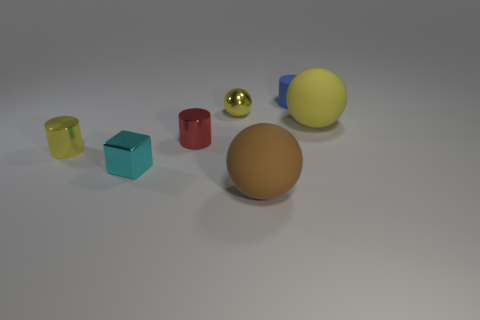The blue matte cylinder has what size?
Make the answer very short. Small. What number of things are yellow spheres or large brown objects?
Provide a succinct answer. 3. There is a tiny sphere that is the same material as the tiny cyan object; what color is it?
Make the answer very short. Yellow. There is a object that is to the right of the tiny blue cylinder; is it the same shape as the cyan metallic thing?
Your response must be concise. No. What number of things are either big spheres to the right of the tiny blue rubber thing or yellow metallic things that are behind the yellow metallic cylinder?
Offer a very short reply. 2. There is another large object that is the same shape as the brown object; what is its color?
Provide a succinct answer. Yellow. Are there any other things that are the same shape as the small red thing?
Keep it short and to the point. Yes. There is a cyan shiny thing; is its shape the same as the big thing to the left of the small blue matte cylinder?
Provide a succinct answer. No. What is the material of the small blue cylinder?
Offer a terse response. Rubber. What size is the rubber object that is the same shape as the red metal object?
Offer a terse response. Small. 